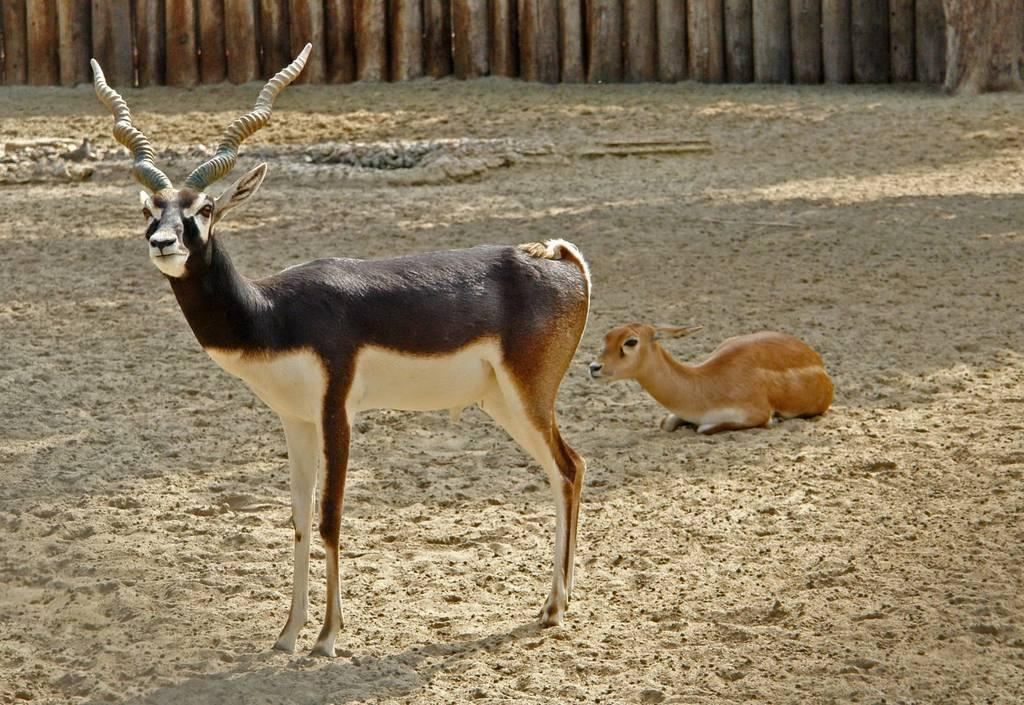What types of living organisms can be seen in the image? There are animals in the image. What material is used to create some of the objects in the image? There are wooden objects in the image. What type of locket can be seen hanging from the neck of one of the animals in the image? There is no locket visible in the image; the animals and wooden objects are the only subjects mentioned in the facts. 